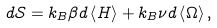<formula> <loc_0><loc_0><loc_500><loc_500>d \mathcal { S } = k _ { B } \beta d \left \langle H \right \rangle + k _ { B } \nu d \left \langle \Omega \right \rangle ,</formula> 